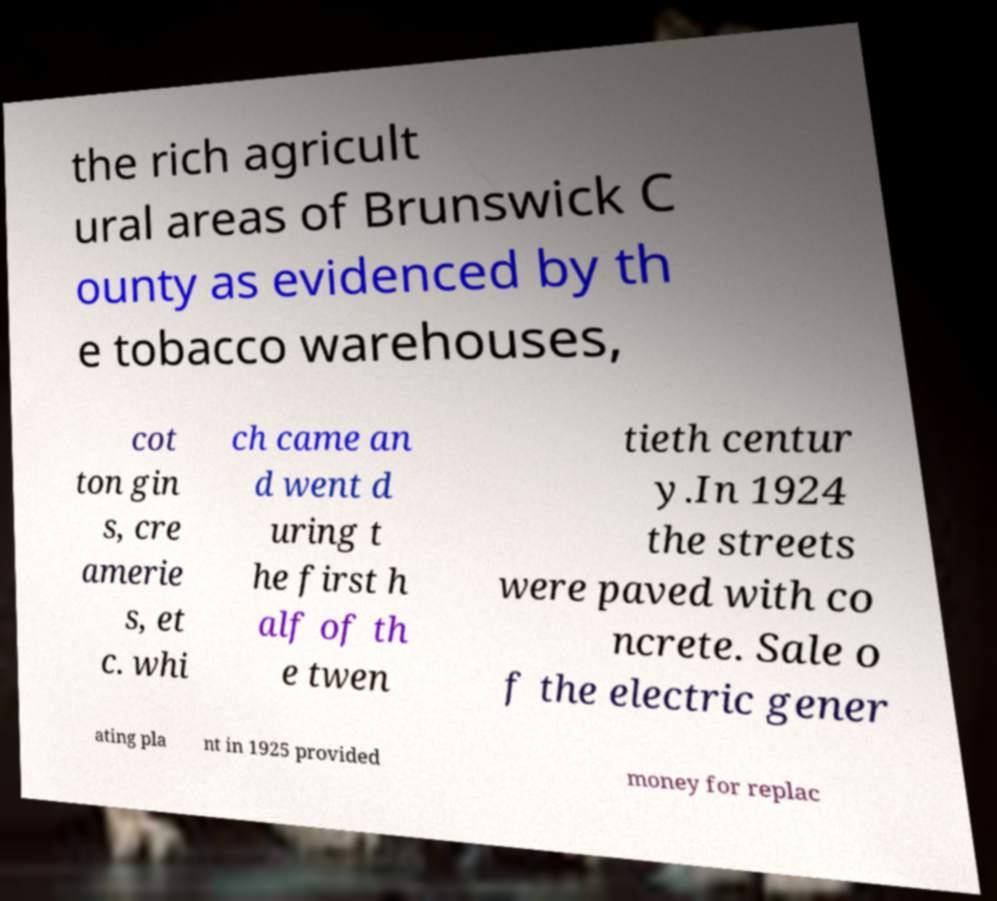For documentation purposes, I need the text within this image transcribed. Could you provide that? the rich agricult ural areas of Brunswick C ounty as evidenced by th e tobacco warehouses, cot ton gin s, cre amerie s, et c. whi ch came an d went d uring t he first h alf of th e twen tieth centur y.In 1924 the streets were paved with co ncrete. Sale o f the electric gener ating pla nt in 1925 provided money for replac 